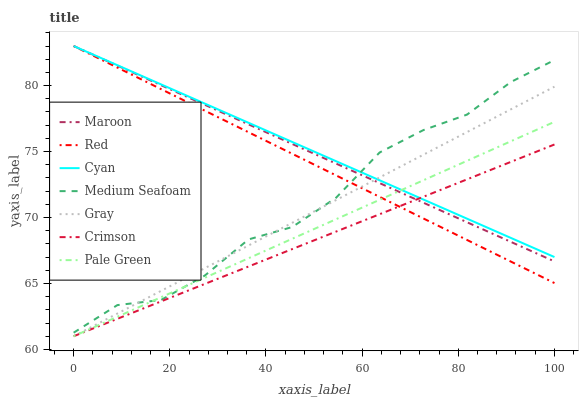Does Crimson have the minimum area under the curve?
Answer yes or no. Yes. Does Cyan have the maximum area under the curve?
Answer yes or no. Yes. Does Maroon have the minimum area under the curve?
Answer yes or no. No. Does Maroon have the maximum area under the curve?
Answer yes or no. No. Is Red the smoothest?
Answer yes or no. Yes. Is Medium Seafoam the roughest?
Answer yes or no. Yes. Is Maroon the smoothest?
Answer yes or no. No. Is Maroon the roughest?
Answer yes or no. No. Does Gray have the lowest value?
Answer yes or no. Yes. Does Maroon have the lowest value?
Answer yes or no. No. Does Red have the highest value?
Answer yes or no. Yes. Does Pale Green have the highest value?
Answer yes or no. No. Is Crimson less than Medium Seafoam?
Answer yes or no. Yes. Is Medium Seafoam greater than Crimson?
Answer yes or no. Yes. Does Cyan intersect Gray?
Answer yes or no. Yes. Is Cyan less than Gray?
Answer yes or no. No. Is Cyan greater than Gray?
Answer yes or no. No. Does Crimson intersect Medium Seafoam?
Answer yes or no. No. 